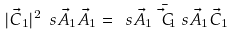<formula> <loc_0><loc_0><loc_500><loc_500>| \vec { C } _ { 1 } | ^ { 2 } \ s { \vec { A } _ { 1 } } { \vec { A } _ { 1 } } = \ s { \vec { A } _ { 1 } } { \bar { \vec { C } _ { 1 } } } \ s { \vec { A } _ { 1 } } { \vec { C } _ { 1 } }</formula> 